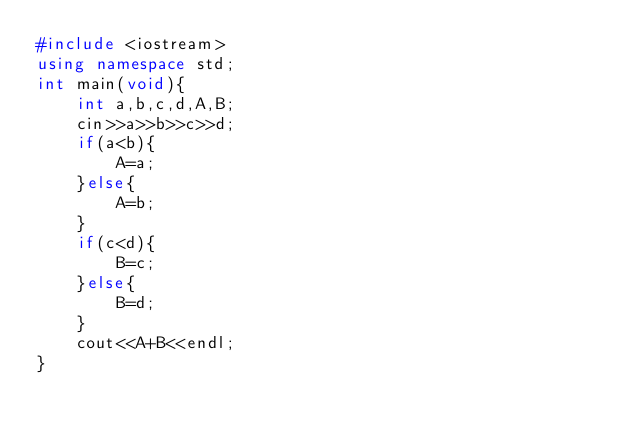Convert code to text. <code><loc_0><loc_0><loc_500><loc_500><_C++_>#include <iostream>
using namespace std;
int main(void){
    int a,b,c,d,A,B;
    cin>>a>>b>>c>>d;
    if(a<b){
        A=a;
    }else{
        A=b;
    }
    if(c<d){
        B=c;
    }else{
        B=d;
    }
    cout<<A+B<<endl;
}
</code> 